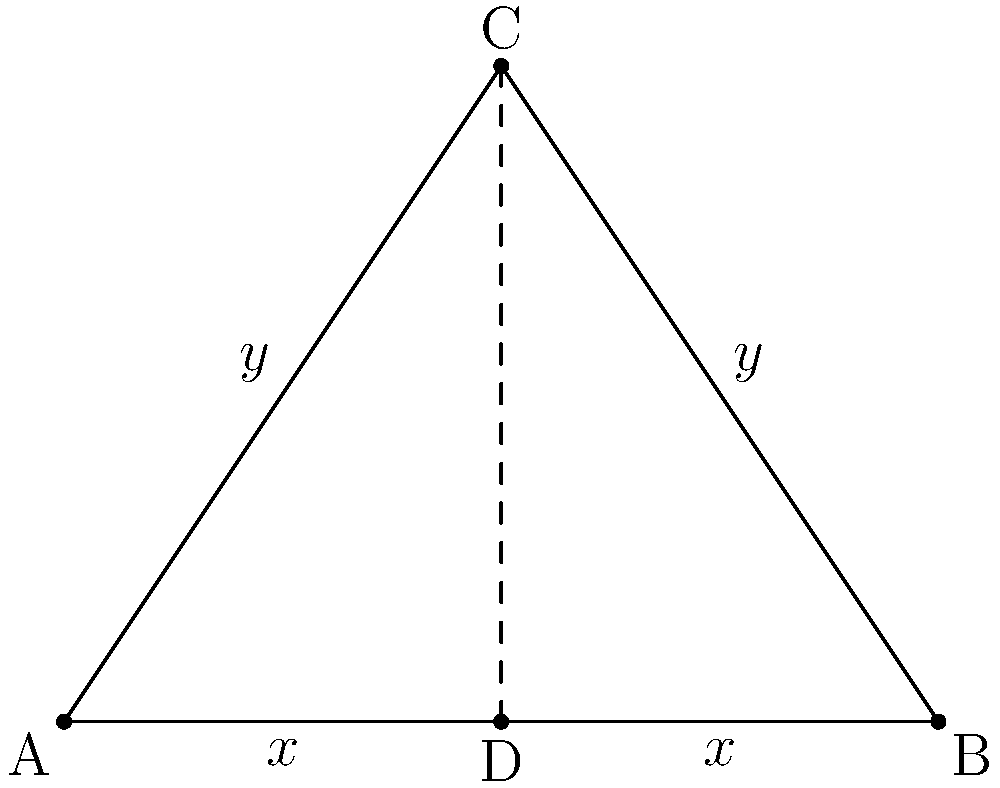In the design of a symmetrical knee prosthesis, the cross-section is represented by an isosceles triangle ABC. If the base of the triangle is 4 cm and the height is 3 cm, what is the length of one of the equal sides (AC or BC) to ensure perfect symmetry and optimal fit? To find the length of one of the equal sides (AC or BC), we can follow these steps:

1) First, we recognize that triangle ABC is isosceles, with AC = BC.

2) The base of the triangle (AB) is given as 4 cm, and the height (CD) is 3 cm.

3) We can split the isosceles triangle into two right triangles by drawing the height CD.

4) In one of these right triangles:
   - The base is half of AB, so AD = DB = 2 cm
   - The height CD is 3 cm

5) We now have a right triangle ACD where:
   - The base (AD) is 2 cm
   - The height (CD) is 3 cm
   - We need to find the hypotenuse (AC)

6) We can use the Pythagorean theorem: $AC^2 = AD^2 + CD^2$

7) Substituting the values:
   $AC^2 = 2^2 + 3^2 = 4 + 9 = 13$

8) Taking the square root of both sides:
   $AC = \sqrt{13}$

Therefore, the length of one of the equal sides (AC or BC) is $\sqrt{13}$ cm.
Answer: $\sqrt{13}$ cm 